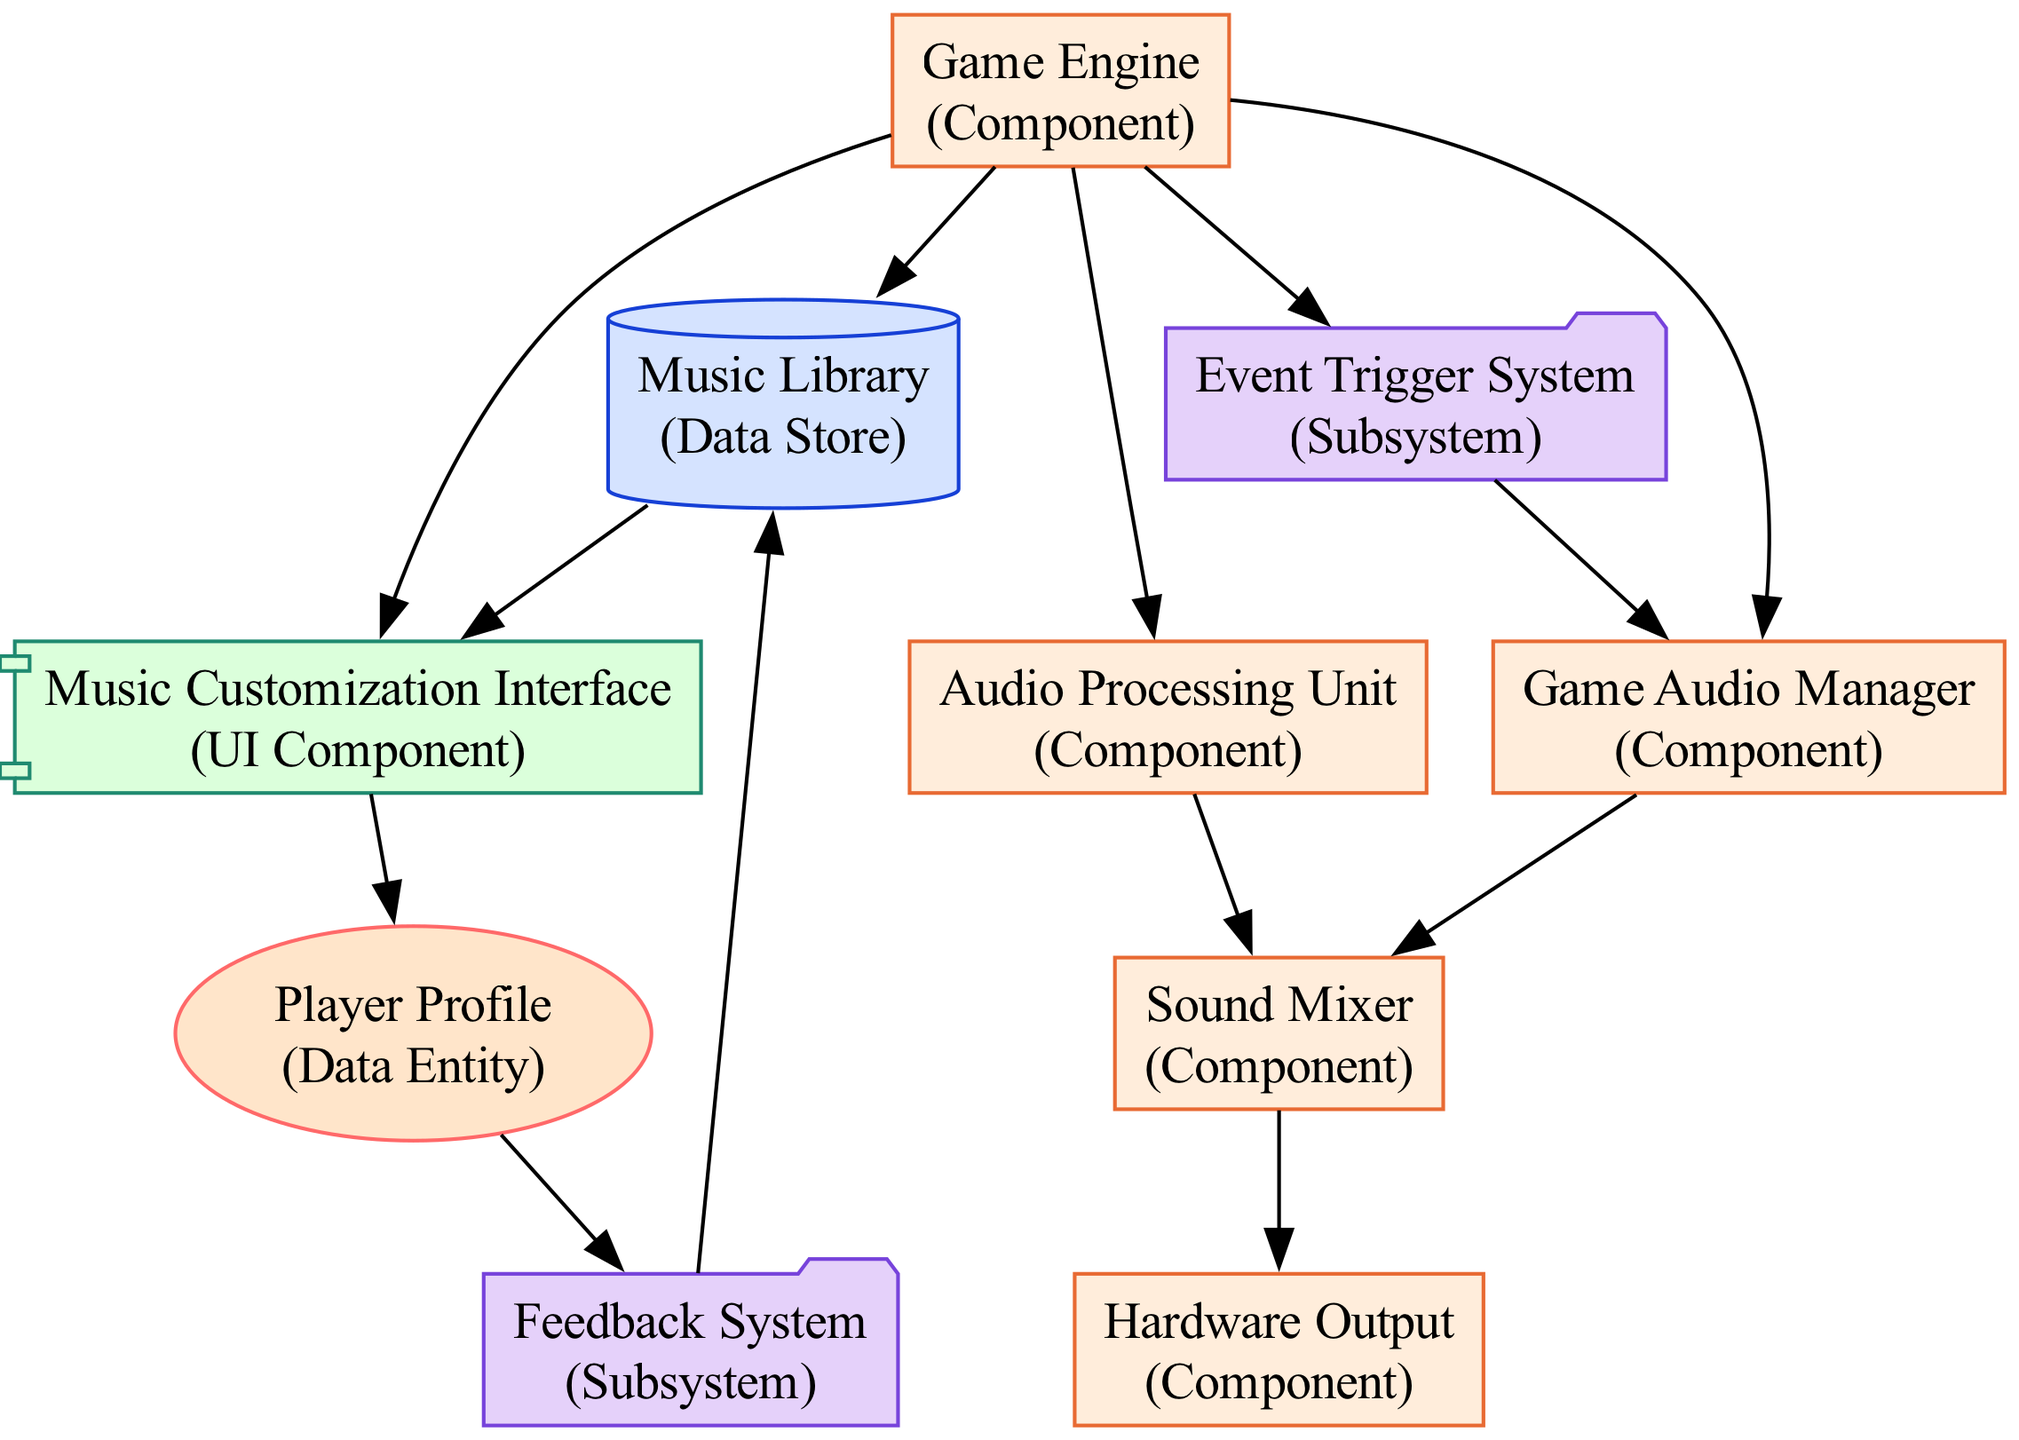What is the type of the "Game Audio Manager"? The "Game Audio Manager" is labeled as a "Component" in the diagram, which defines its role within the overall system.
Answer: Component How many nodes are present in the diagram? By counting each unique element in the diagram, we find a total of ten nodes including various components, data stores, and interfaces.
Answer: 10 Which component connects directly to the "Music Library"? The "Game Engine" connects directly to the "Music Library" as indicated by the diagram’s directional edge between them.
Answer: Game Engine What type of component is the "Feedback System"? The "Feedback System" is categorized as a "Subsystem," which is identified by its type description and visual representation in the diagram.
Answer: Subsystem Which two components share a direct connection with the "Sound Mixer"? The "Audio Processing Unit" and the "Game Audio Manager" both have direct connections to the "Sound Mixer" as shown in the diagram.
Answer: Audio Processing Unit and Game Audio Manager What is the relationship between "Player Profile" and "Music Customization Interface"? The "Player Profile" is connected to the "Music Customization Interface," indicating that player settings and preferences influence song selection or customization options.
Answer: Direct connection Which element is at the termination point for audio output? The "Hardware Output" is the final element connected to the system, receiving the processed audio to deliver it to the player.
Answer: Hardware Output How does the "Event Trigger System" influence the "Game Audio Manager"? The "Event Trigger System" monitors game events to provide input for music changes, which directly affects the functioning of the "Game Audio Manager."
Answer: Influences directly What function does the "Audio Processing Unit" serve? The "Audio Processing Unit" is responsible for preprocessing and rendering audio tracks before they are mixed and outputted, as specified in the diagram.
Answer: Preprocessing and rendering audio tracks What feedback mechanism is integrated into the system? The "Feedback System" collects player feedback on music and gameplay to improve future selections and options catering to player preferences.
Answer: Player feedback collection 